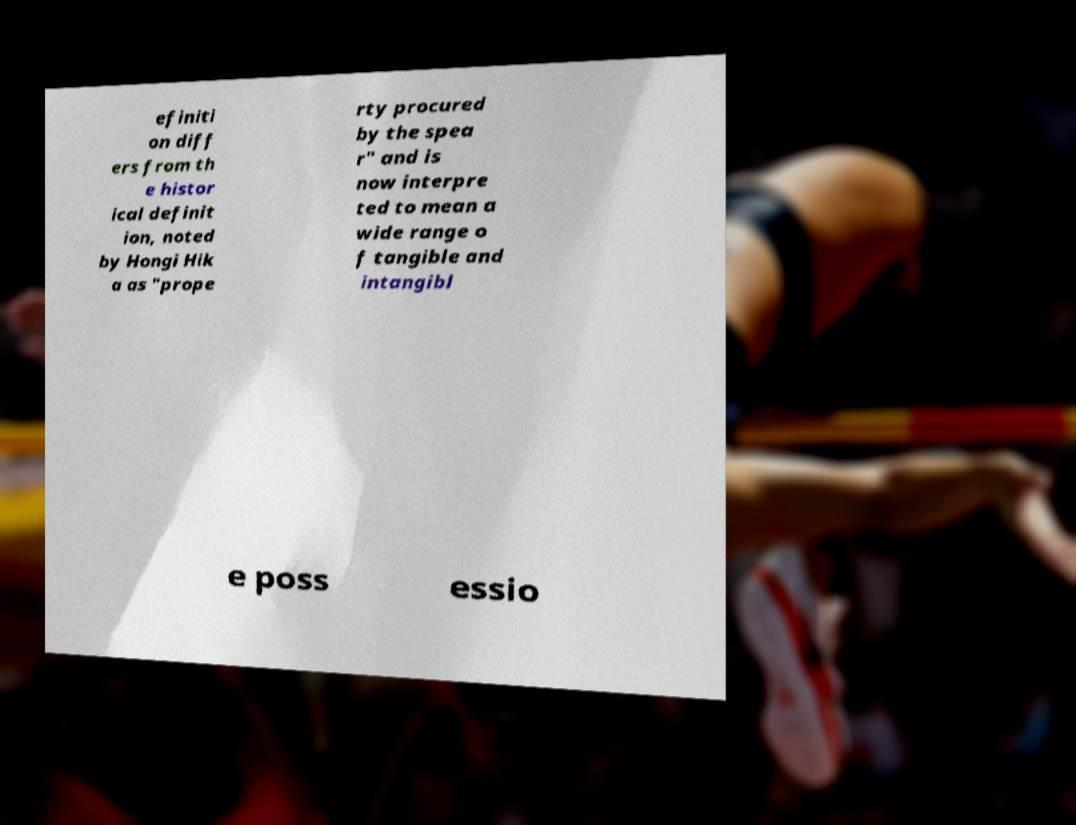Could you extract and type out the text from this image? efiniti on diff ers from th e histor ical definit ion, noted by Hongi Hik a as "prope rty procured by the spea r" and is now interpre ted to mean a wide range o f tangible and intangibl e poss essio 